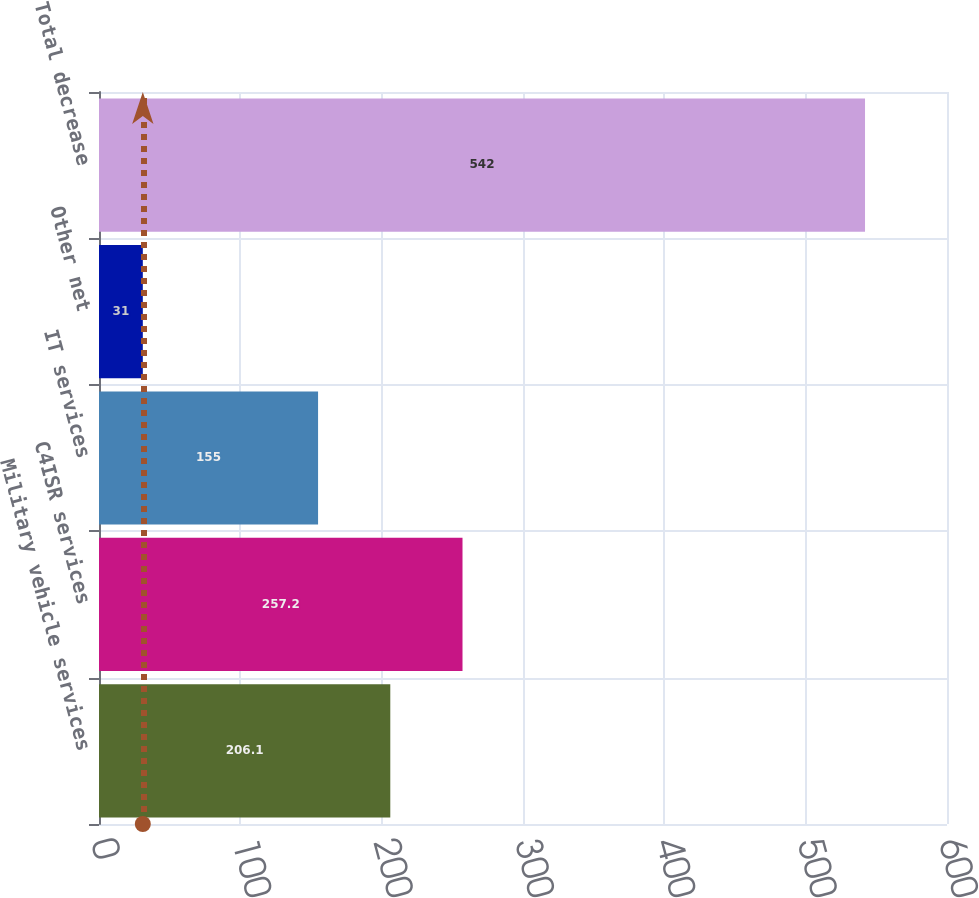<chart> <loc_0><loc_0><loc_500><loc_500><bar_chart><fcel>Military vehicle services<fcel>C4ISR services<fcel>IT services<fcel>Other net<fcel>Total decrease<nl><fcel>206.1<fcel>257.2<fcel>155<fcel>31<fcel>542<nl></chart> 